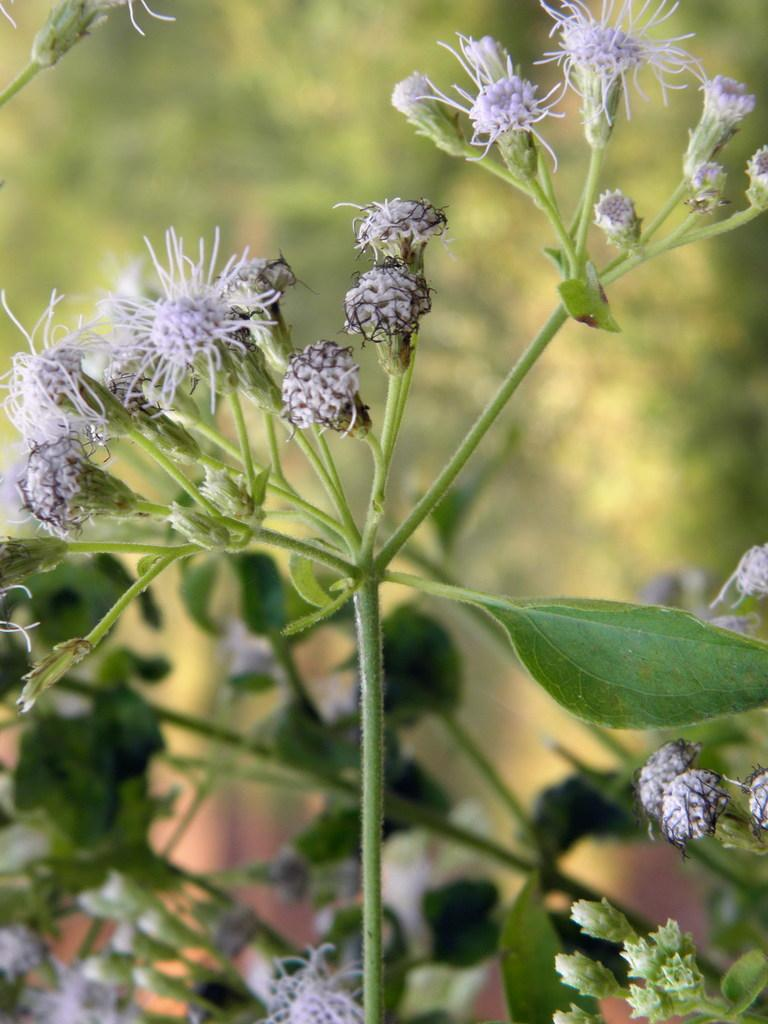What type of plant is visible in the image? There is a plant in the image, and it has flowers and green leaves. What can be observed about the plant's flowers? The plant has flowers, which are visible in the image. What color are the leaves of the plant? The leaves of the plant are green. How would you describe the background of the image? The background of the image is blurred. Are there any coils visible in the image? There are no coils present in the image; it features a plant with flowers and green leaves. Can you see any mountains in the background of the image? There are no mountains visible in the image; the background is blurred. 